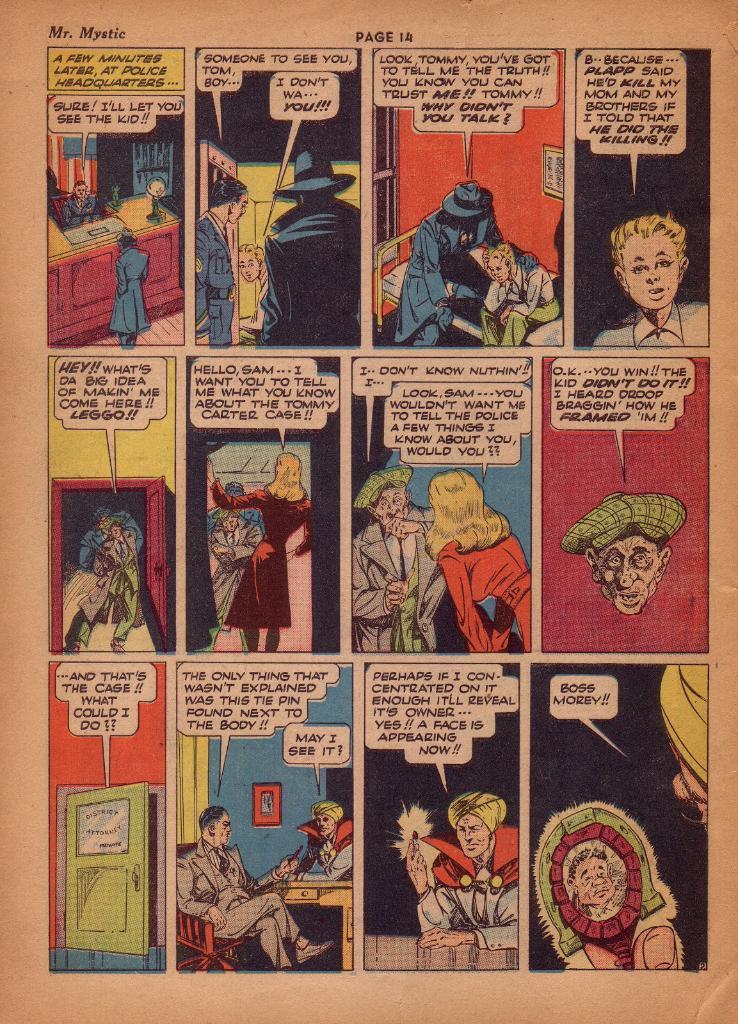Please provide a concise description of this image. It is a poster. In this image there are depictions of people and there is text on the image. 